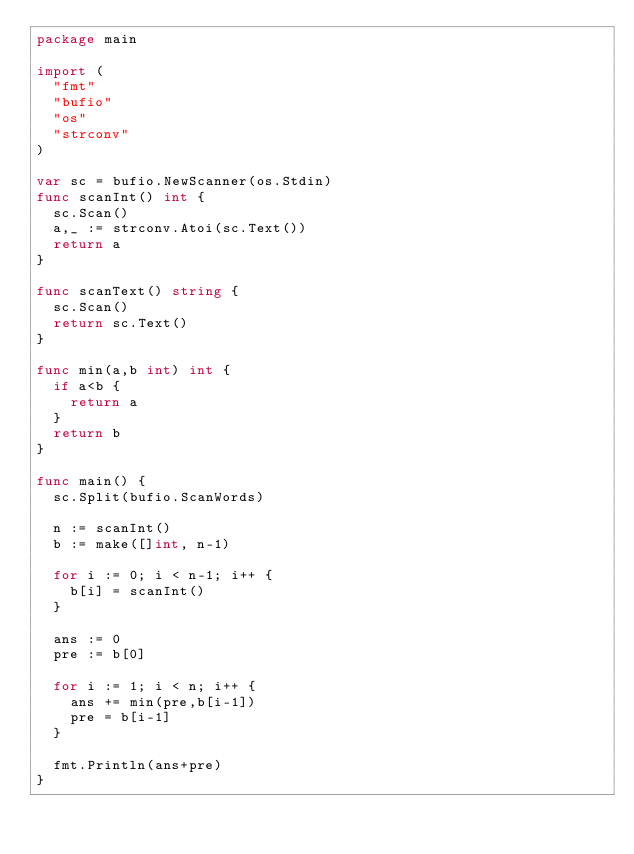Convert code to text. <code><loc_0><loc_0><loc_500><loc_500><_Go_>package main

import (
	"fmt"
	"bufio"
	"os"
	"strconv"
)

var sc = bufio.NewScanner(os.Stdin)
func scanInt() int {
	sc.Scan()
	a,_ := strconv.Atoi(sc.Text())
	return a
}

func scanText() string {
	sc.Scan()
	return sc.Text()
}

func min(a,b int) int {
	if a<b {
		return a
	}
	return b
}

func main() {
	sc.Split(bufio.ScanWords)
	
	n := scanInt()
	b := make([]int, n-1)

	for i := 0; i < n-1; i++ {
		b[i] = scanInt()
	}
	
	ans := 0
	pre := b[0]

	for i := 1; i < n; i++ {
		ans += min(pre,b[i-1])
		pre = b[i-1]
	}
	
	fmt.Println(ans+pre)
}
</code> 